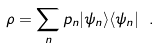Convert formula to latex. <formula><loc_0><loc_0><loc_500><loc_500>\rho = \sum _ { n } p _ { n } | \psi _ { n } \rangle \langle \psi _ { n } | \ .</formula> 